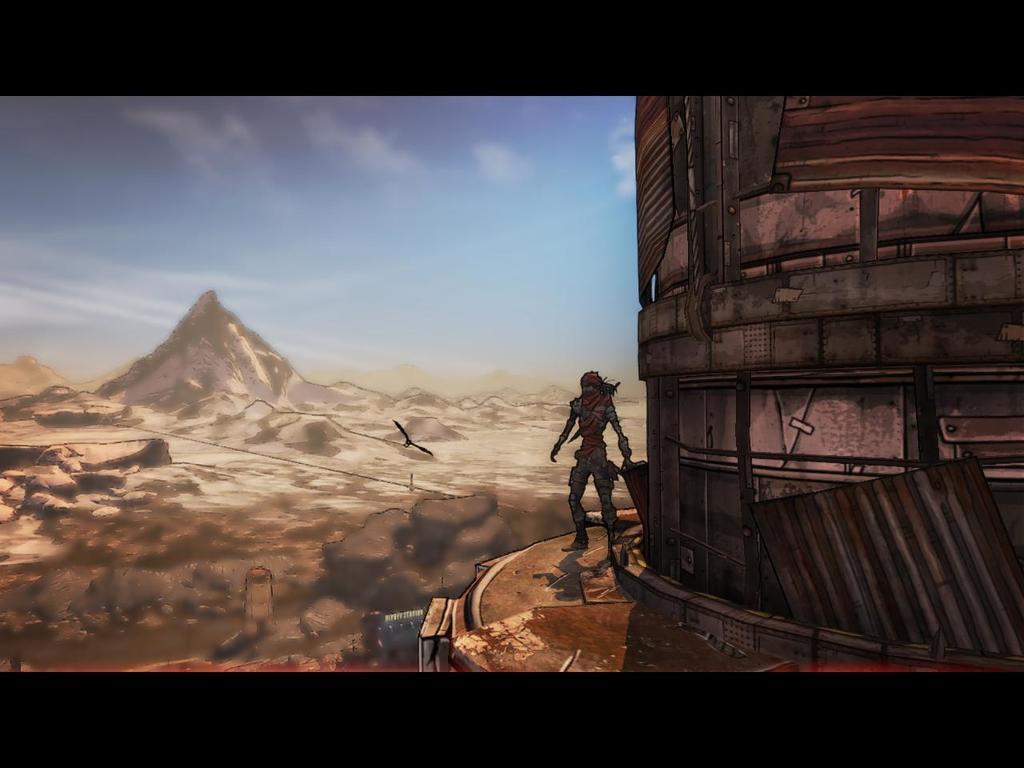Could you give a brief overview of what you see in this image? In this image I can see the digital art in which I can see a huge building, a person standing and in the background I can see the ground, a bird flying in the air, a mountain and the sky. 